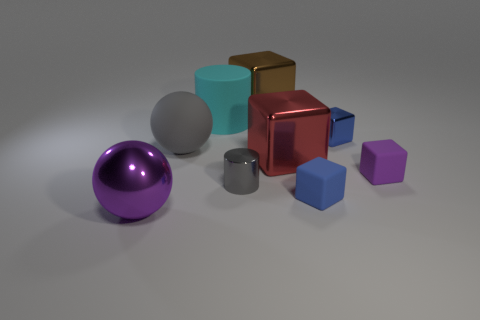Subtract all big blocks. How many blocks are left? 3 Add 1 large red metallic cubes. How many objects exist? 10 Subtract all gray spheres. How many spheres are left? 1 Subtract all cylinders. How many objects are left? 7 Subtract all purple balls. How many gray cylinders are left? 1 Subtract all big green balls. Subtract all purple blocks. How many objects are left? 8 Add 3 big red objects. How many big red objects are left? 4 Add 2 large brown balls. How many large brown balls exist? 2 Subtract 0 blue cylinders. How many objects are left? 9 Subtract 2 blocks. How many blocks are left? 3 